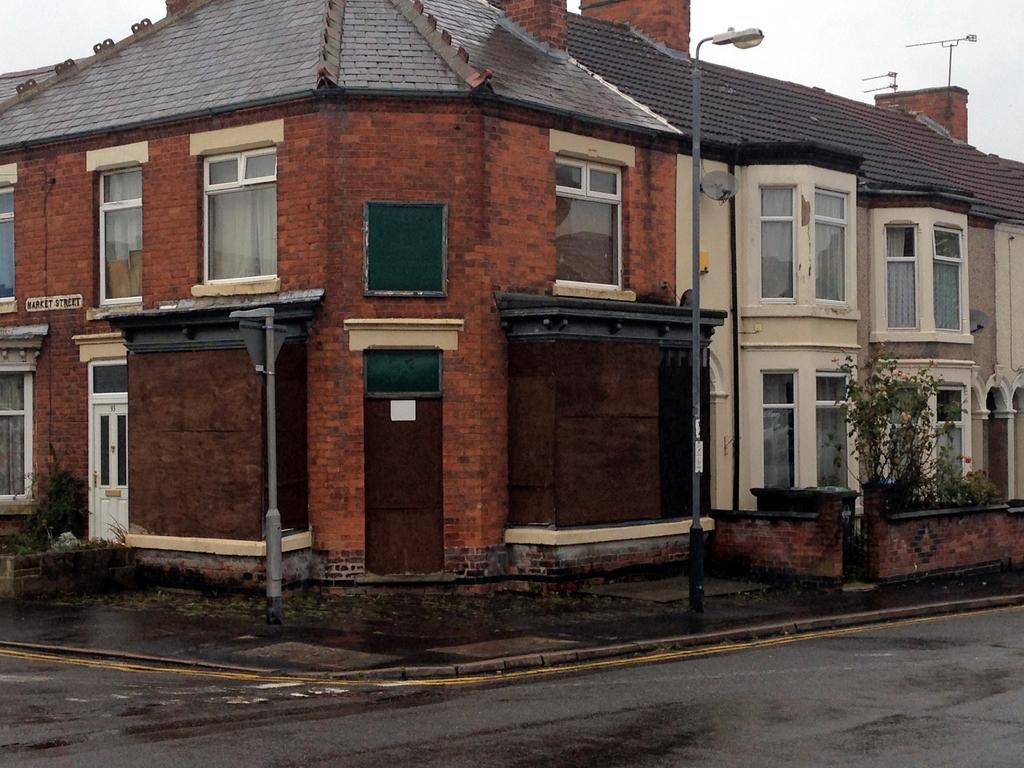What is located in the center of the image? There are buildings and poles in the center of the image. What type of vegetation can be seen in the image? There are plants visible in the image. What is at the bottom of the image? There is a road at the bottom of the image. How many flowers are growing on the poles in the image? There are no flowers growing on the poles in the image. What invention is being demonstrated by the plants in the image? There is no invention being demonstrated by the plants in the image; they are simply visible vegetation. 